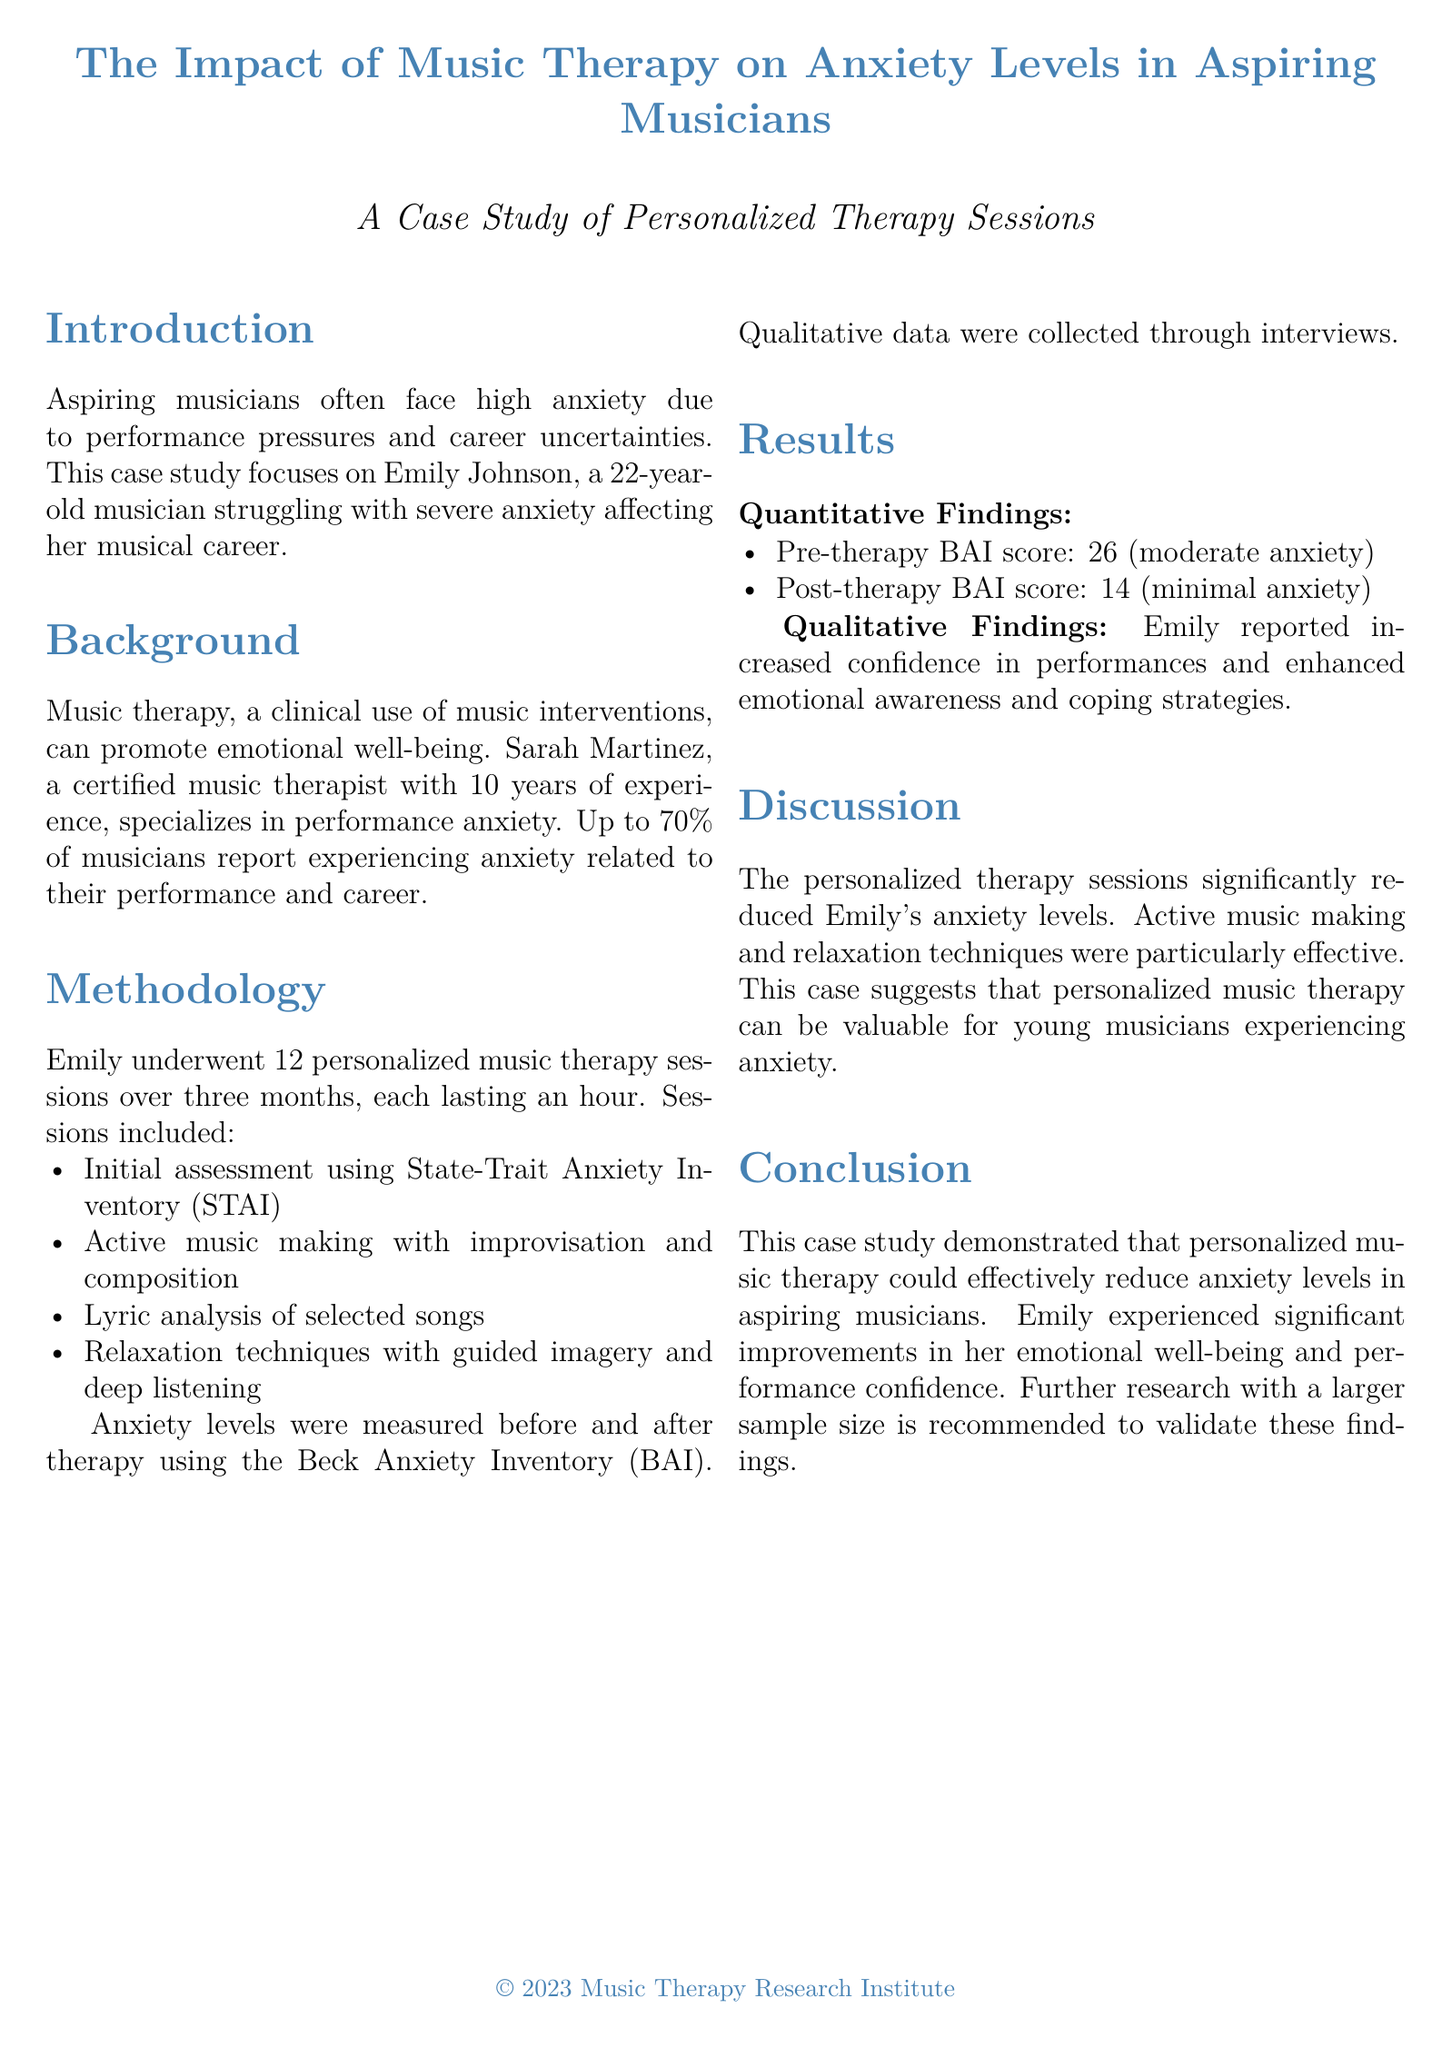What is the name of the musician in the case study? The case study focuses on Emily Johnson, a musician struggling with anxiety.
Answer: Emily Johnson How many therapy sessions did Emily undergo? Emily completed a total of 12 personalized therapy sessions over three months.
Answer: 12 What was Emily's pre-therapy BAI score? The document states that Emily's pre-therapy BAI score was 26, indicating moderate anxiety.
Answer: 26 What technique was notably effective in reducing anxiety levels? Active music making and relaxation techniques were identified as particularly effective in the therapy.
Answer: Active music making Who is the music therapist mentioned in the study? Sarah Martinez, a certified music therapist with 10 years of experience, is mentioned in the study.
Answer: Sarah Martinez What type of music therapy was primarily used? The primary intervention used in the case study was personalized music therapy focused on performance anxiety.
Answer: Personalized music therapy What was Emily's post-therapy BAI score? The post-therapy BAI score reported for Emily was 14, indicating minimal anxiety.
Answer: 14 What does the conclusion of the case study suggest? The conclusion suggests that personalized music therapy can effectively reduce anxiety levels in aspiring musicians.
Answer: Effective reduction of anxiety What qualitative improvement did Emily experience? Emily reported increased confidence in her performances and enhanced emotional awareness.
Answer: Increased confidence 